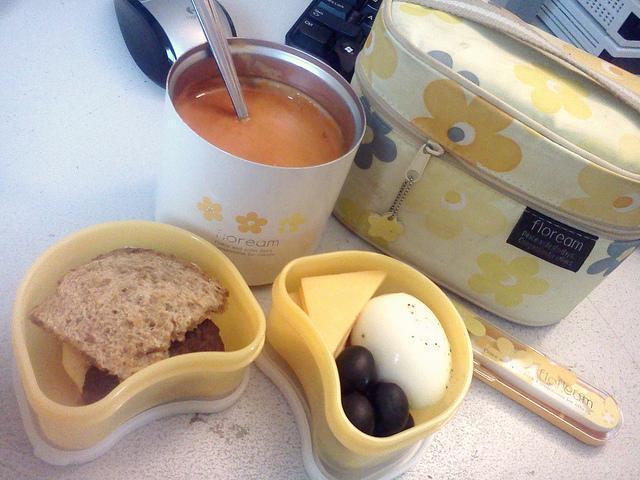What does the item in the can with the utensil look like?
Select the accurate answer and provide justification: `Answer: choice
Rationale: srationale.`
Options: Cake, soup, cat, pears. Answer: soup.
Rationale: The stuff in the can looks like soup to go with the sandwich. 